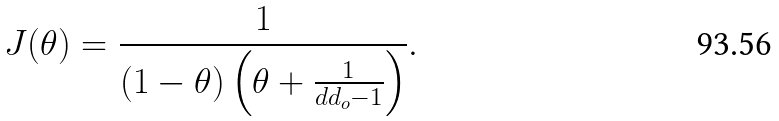<formula> <loc_0><loc_0><loc_500><loc_500>J ( \theta ) = \frac { 1 } { ( 1 - \theta ) \left ( \theta + \frac { 1 } { d d _ { o } - 1 } \right ) } .</formula> 